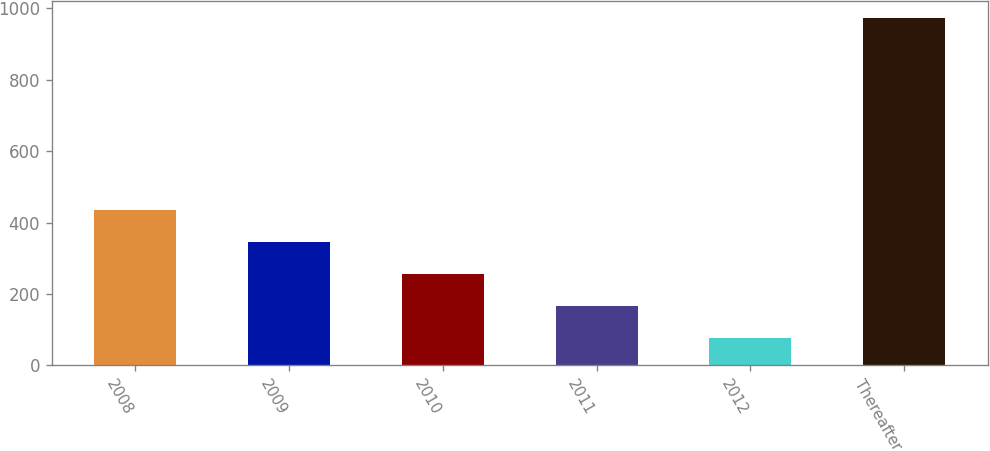Convert chart to OTSL. <chart><loc_0><loc_0><loc_500><loc_500><bar_chart><fcel>2008<fcel>2009<fcel>2010<fcel>2011<fcel>2012<fcel>Thereafter<nl><fcel>435.44<fcel>345.93<fcel>256.42<fcel>166.91<fcel>77.4<fcel>972.5<nl></chart> 